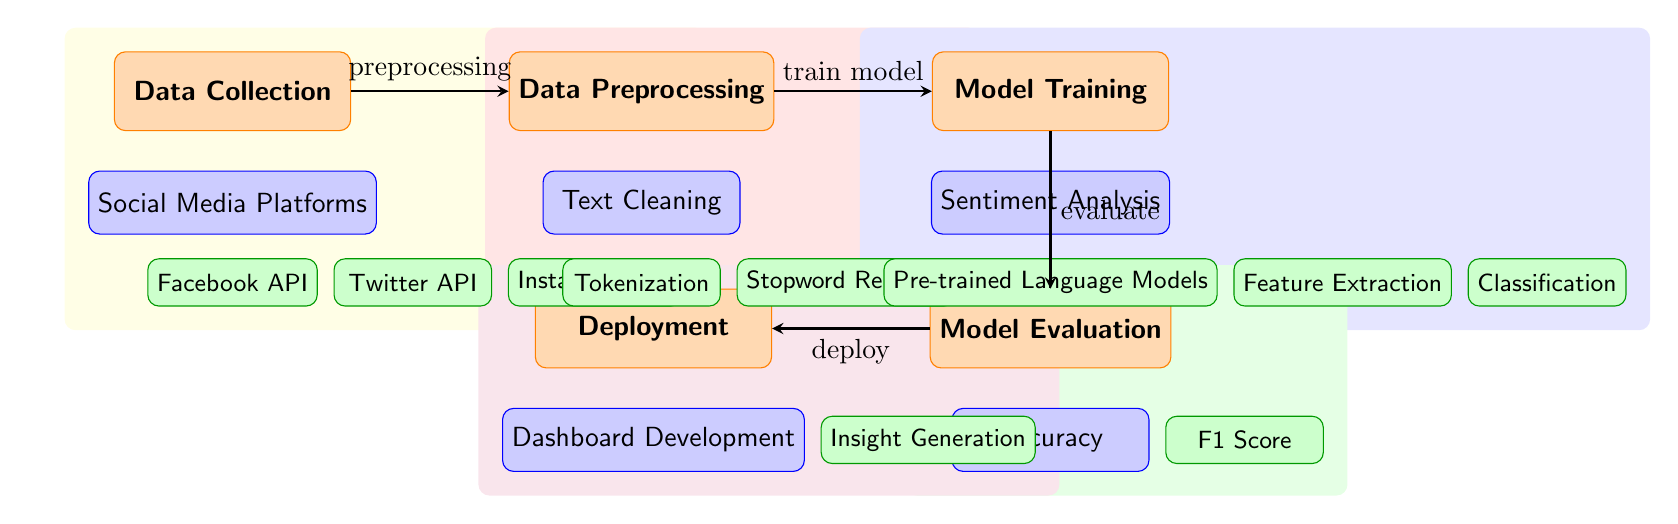What is the first process in the diagram? The first process listed at the top of the diagram is "Data Collection." This is the initial step towards gathering data needed for the analysis.
Answer: Data Collection How many subprocesses are there under Data Collection? Under the "Data Collection" node, there are three subprocesses: "Social Media Platforms," "Facebook API," "Twitter API," and "Instagram API." Counting these gives a total of three subprocesses.
Answer: 3 What comes after Data Preprocessing in the flow? Following the "Data Preprocessing" node in the flow, the next step is "Model Training." This sequential relationship is indicated by the arrow connecting these two processes.
Answer: Model Training Which subprocess is related to cleaning text data? The subprocess responsible for cleaning text data is "Text Cleaning." It appears directly under the "Data Preprocessing" process and focuses specifically on preparing textual content for further analysis.
Answer: Text Cleaning What are the evaluation metrics listed within the Model Evaluation process? Within the "Model Evaluation" process, the evaluation metric highlighted is "Accuracy." Additionally, the F1 Score is listed as a subprocess under "Accuracy," indicating it is another measure being tracked.
Answer: Accuracy Which subprocess is concerned with generating insights? The subprocess that focuses on generating insights is "Insight Generation." It is part of the "Deployment" phase and aims to present findings based on the analysis of the sentiment data.
Answer: Insight Generation How many main processes are shown in the diagram? The diagram displays five main processes: "Data Collection," "Data Preprocessing," "Model Training," "Model Evaluation," and "Deployment." This count includes all top-level processes without subprocesses.
Answer: 5 What type of models are pre-trained for sentiment analysis? The type of models that are pre-trained for sentiment analysis is referred to as "Pre-trained Language Models." This indicates that existing models are being utilized to analyze sentiment data from social media.
Answer: Pre-trained Language Models What is the connecting action between Model Training and Model Evaluation? The connecting action between "Model Training" and "Model Evaluation" is labeled as "evaluate." This suggests the transition from training the model to assessing its performance based on designated metrics.
Answer: evaluate 